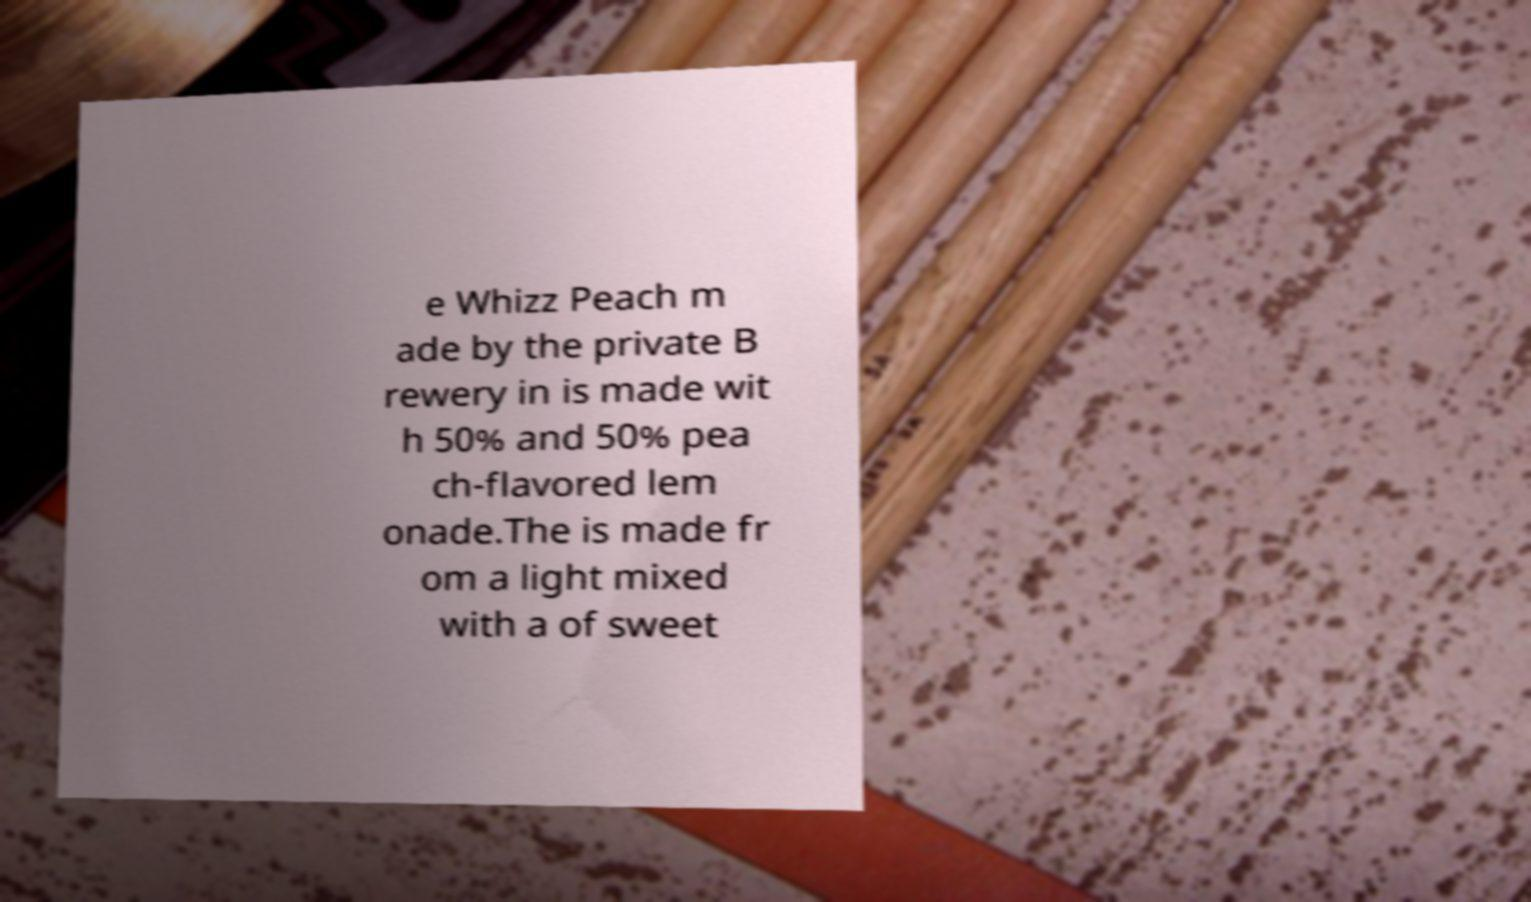Please identify and transcribe the text found in this image. e Whizz Peach m ade by the private B rewery in is made wit h 50% and 50% pea ch-flavored lem onade.The is made fr om a light mixed with a of sweet 